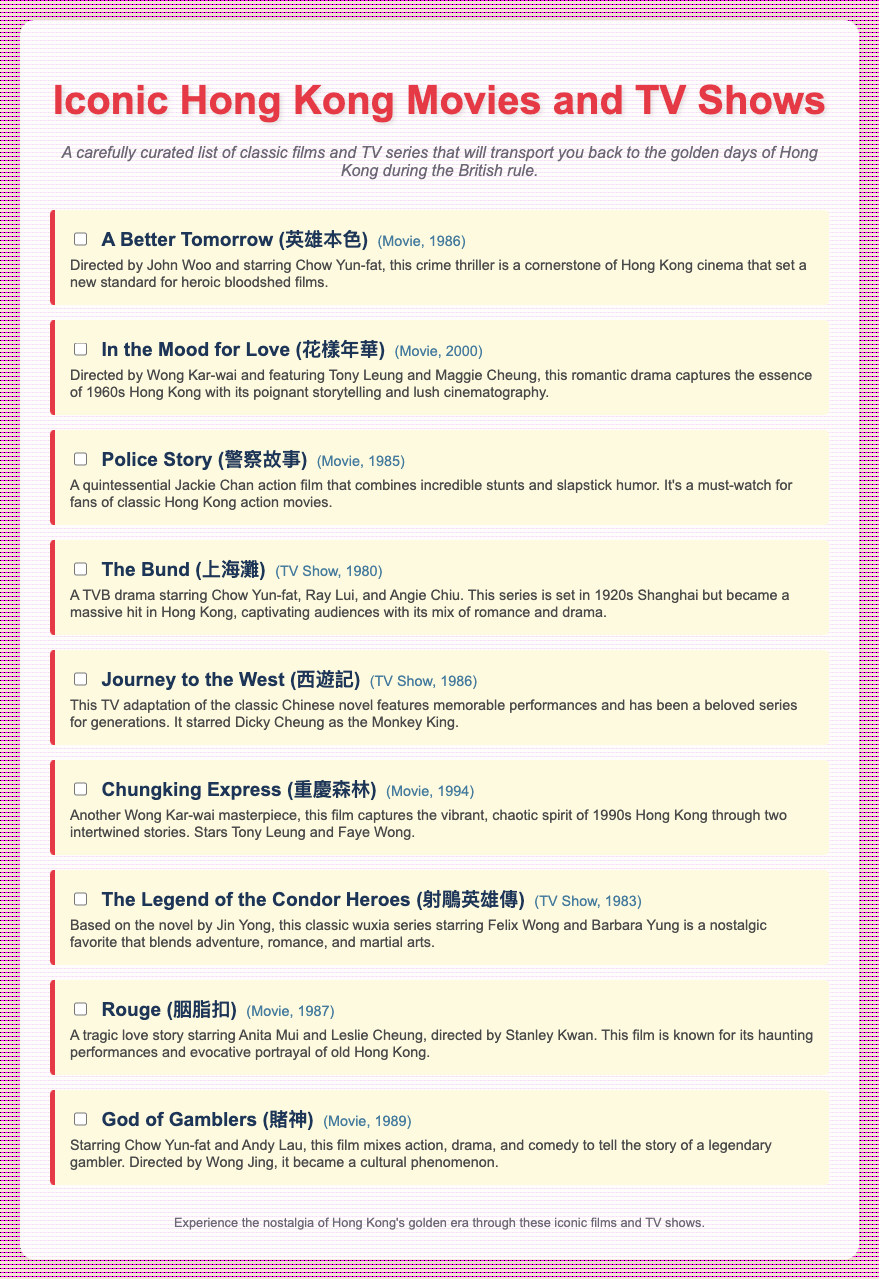what is the title of the first movie in the checklist? The title of the first movie is listed at the top of the checklist as "A Better Tomorrow".
Answer: A Better Tomorrow who directed "In the Mood for Love"? The director of "In the Mood for Love" is mentioned directly in the description of the movie.
Answer: Wong Kar-wai how many TV shows are included in the checklist? The checklist includes a specific number of TV shows, which can be counted from the list.
Answer: 3 what year was "Police Story" released? The release year for "Police Story" is noted next to the title in the checklist.
Answer: 1985 which actor starred in "Rouge"? The actor starring in "Rouge" is listed in the movie description.
Answer: Anita Mui name one movie directed by Wong Kar-wai from the checklist. The checklist explicitly states one of Wong Kar-wai's directorial movies.
Answer: In the Mood for Love what genre does "Journey to the West" belong to? The genre of "Journey to the West" can be derived from its description.
Answer: TV Show what is the main theme of "God of Gamblers"? The main theme is stated in the description as the story revolves around a specific character.
Answer: Legendary gambler 